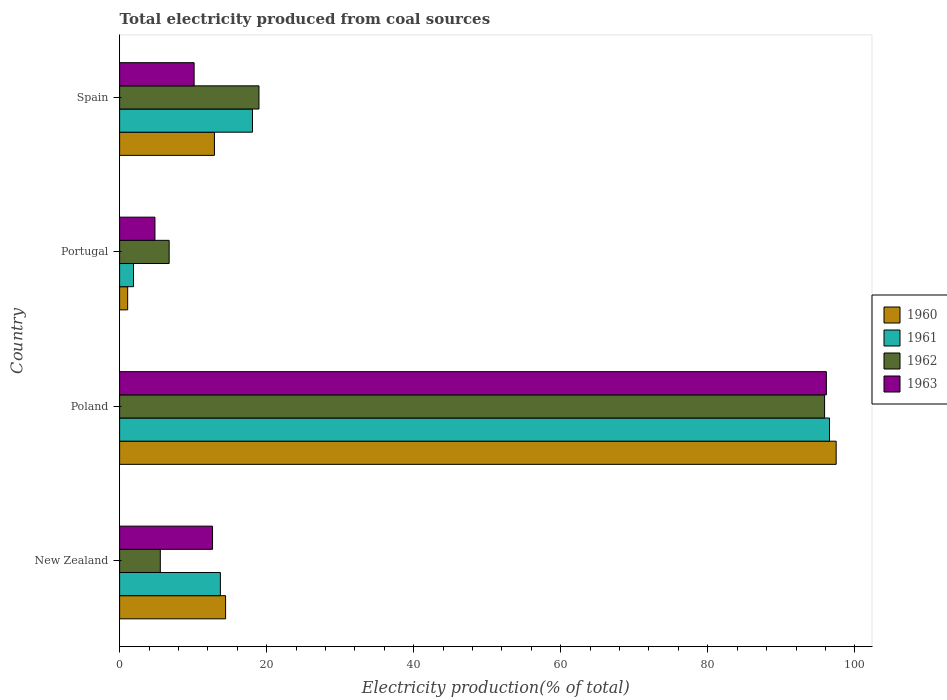How many different coloured bars are there?
Provide a short and direct response. 4. How many groups of bars are there?
Provide a short and direct response. 4. Are the number of bars on each tick of the Y-axis equal?
Provide a succinct answer. Yes. How many bars are there on the 4th tick from the top?
Ensure brevity in your answer.  4. In how many cases, is the number of bars for a given country not equal to the number of legend labels?
Offer a very short reply. 0. What is the total electricity produced in 1960 in New Zealand?
Make the answer very short. 14.42. Across all countries, what is the maximum total electricity produced in 1962?
Provide a short and direct response. 95.89. Across all countries, what is the minimum total electricity produced in 1960?
Provide a succinct answer. 1.1. In which country was the total electricity produced in 1962 minimum?
Provide a succinct answer. New Zealand. What is the total total electricity produced in 1960 in the graph?
Keep it short and to the point. 125.88. What is the difference between the total electricity produced in 1963 in New Zealand and that in Poland?
Your answer should be very brief. -83.49. What is the difference between the total electricity produced in 1962 in Poland and the total electricity produced in 1960 in Portugal?
Keep it short and to the point. 94.79. What is the average total electricity produced in 1961 per country?
Keep it short and to the point. 32.56. What is the difference between the total electricity produced in 1961 and total electricity produced in 1963 in Portugal?
Provide a succinct answer. -2.91. In how many countries, is the total electricity produced in 1963 greater than 88 %?
Your answer should be very brief. 1. What is the ratio of the total electricity produced in 1963 in Poland to that in Portugal?
Keep it short and to the point. 19.99. Is the total electricity produced in 1961 in Portugal less than that in Spain?
Ensure brevity in your answer.  Yes. Is the difference between the total electricity produced in 1961 in New Zealand and Portugal greater than the difference between the total electricity produced in 1963 in New Zealand and Portugal?
Your response must be concise. Yes. What is the difference between the highest and the second highest total electricity produced in 1962?
Offer a terse response. 76.93. What is the difference between the highest and the lowest total electricity produced in 1961?
Provide a succinct answer. 94.66. In how many countries, is the total electricity produced in 1961 greater than the average total electricity produced in 1961 taken over all countries?
Your response must be concise. 1. What does the 3rd bar from the bottom in Poland represents?
Offer a terse response. 1962. Are all the bars in the graph horizontal?
Offer a very short reply. Yes. Are the values on the major ticks of X-axis written in scientific E-notation?
Provide a succinct answer. No. Does the graph contain grids?
Your answer should be very brief. No. How many legend labels are there?
Keep it short and to the point. 4. What is the title of the graph?
Provide a short and direct response. Total electricity produced from coal sources. Does "1998" appear as one of the legend labels in the graph?
Offer a terse response. No. What is the label or title of the Y-axis?
Your answer should be very brief. Country. What is the Electricity production(% of total) in 1960 in New Zealand?
Provide a short and direct response. 14.42. What is the Electricity production(% of total) in 1961 in New Zealand?
Offer a very short reply. 13.71. What is the Electricity production(% of total) of 1962 in New Zealand?
Provide a short and direct response. 5.54. What is the Electricity production(% of total) of 1963 in New Zealand?
Give a very brief answer. 12.64. What is the Electricity production(% of total) in 1960 in Poland?
Your response must be concise. 97.46. What is the Electricity production(% of total) of 1961 in Poland?
Your answer should be compact. 96.56. What is the Electricity production(% of total) of 1962 in Poland?
Provide a succinct answer. 95.89. What is the Electricity production(% of total) in 1963 in Poland?
Your answer should be compact. 96.13. What is the Electricity production(% of total) of 1960 in Portugal?
Offer a very short reply. 1.1. What is the Electricity production(% of total) in 1961 in Portugal?
Make the answer very short. 1.89. What is the Electricity production(% of total) in 1962 in Portugal?
Offer a very short reply. 6.74. What is the Electricity production(% of total) in 1963 in Portugal?
Provide a short and direct response. 4.81. What is the Electricity production(% of total) in 1960 in Spain?
Your response must be concise. 12.9. What is the Electricity production(% of total) in 1961 in Spain?
Your answer should be compact. 18.07. What is the Electricity production(% of total) of 1962 in Spain?
Give a very brief answer. 18.96. What is the Electricity production(% of total) in 1963 in Spain?
Provide a short and direct response. 10.14. Across all countries, what is the maximum Electricity production(% of total) of 1960?
Keep it short and to the point. 97.46. Across all countries, what is the maximum Electricity production(% of total) of 1961?
Offer a very short reply. 96.56. Across all countries, what is the maximum Electricity production(% of total) in 1962?
Your answer should be compact. 95.89. Across all countries, what is the maximum Electricity production(% of total) in 1963?
Offer a terse response. 96.13. Across all countries, what is the minimum Electricity production(% of total) of 1960?
Offer a terse response. 1.1. Across all countries, what is the minimum Electricity production(% of total) of 1961?
Offer a terse response. 1.89. Across all countries, what is the minimum Electricity production(% of total) of 1962?
Make the answer very short. 5.54. Across all countries, what is the minimum Electricity production(% of total) in 1963?
Ensure brevity in your answer.  4.81. What is the total Electricity production(% of total) in 1960 in the graph?
Give a very brief answer. 125.88. What is the total Electricity production(% of total) of 1961 in the graph?
Offer a terse response. 130.23. What is the total Electricity production(% of total) of 1962 in the graph?
Provide a succinct answer. 127.12. What is the total Electricity production(% of total) of 1963 in the graph?
Keep it short and to the point. 123.72. What is the difference between the Electricity production(% of total) of 1960 in New Zealand and that in Poland?
Give a very brief answer. -83.05. What is the difference between the Electricity production(% of total) in 1961 in New Zealand and that in Poland?
Offer a terse response. -82.85. What is the difference between the Electricity production(% of total) in 1962 in New Zealand and that in Poland?
Offer a very short reply. -90.35. What is the difference between the Electricity production(% of total) of 1963 in New Zealand and that in Poland?
Keep it short and to the point. -83.49. What is the difference between the Electricity production(% of total) in 1960 in New Zealand and that in Portugal?
Make the answer very short. 13.32. What is the difference between the Electricity production(% of total) of 1961 in New Zealand and that in Portugal?
Your answer should be compact. 11.81. What is the difference between the Electricity production(% of total) of 1962 in New Zealand and that in Portugal?
Your answer should be compact. -1.2. What is the difference between the Electricity production(% of total) of 1963 in New Zealand and that in Portugal?
Ensure brevity in your answer.  7.83. What is the difference between the Electricity production(% of total) of 1960 in New Zealand and that in Spain?
Make the answer very short. 1.52. What is the difference between the Electricity production(% of total) of 1961 in New Zealand and that in Spain?
Your response must be concise. -4.36. What is the difference between the Electricity production(% of total) of 1962 in New Zealand and that in Spain?
Provide a succinct answer. -13.42. What is the difference between the Electricity production(% of total) of 1963 in New Zealand and that in Spain?
Offer a terse response. 2.5. What is the difference between the Electricity production(% of total) in 1960 in Poland and that in Portugal?
Ensure brevity in your answer.  96.36. What is the difference between the Electricity production(% of total) in 1961 in Poland and that in Portugal?
Offer a very short reply. 94.66. What is the difference between the Electricity production(% of total) in 1962 in Poland and that in Portugal?
Offer a very short reply. 89.15. What is the difference between the Electricity production(% of total) in 1963 in Poland and that in Portugal?
Your answer should be compact. 91.32. What is the difference between the Electricity production(% of total) in 1960 in Poland and that in Spain?
Offer a terse response. 84.56. What is the difference between the Electricity production(% of total) in 1961 in Poland and that in Spain?
Your answer should be very brief. 78.49. What is the difference between the Electricity production(% of total) in 1962 in Poland and that in Spain?
Keep it short and to the point. 76.93. What is the difference between the Electricity production(% of total) of 1963 in Poland and that in Spain?
Your answer should be compact. 86. What is the difference between the Electricity production(% of total) of 1960 in Portugal and that in Spain?
Make the answer very short. -11.8. What is the difference between the Electricity production(% of total) in 1961 in Portugal and that in Spain?
Provide a short and direct response. -16.18. What is the difference between the Electricity production(% of total) in 1962 in Portugal and that in Spain?
Offer a terse response. -12.22. What is the difference between the Electricity production(% of total) in 1963 in Portugal and that in Spain?
Your answer should be very brief. -5.33. What is the difference between the Electricity production(% of total) in 1960 in New Zealand and the Electricity production(% of total) in 1961 in Poland?
Ensure brevity in your answer.  -82.14. What is the difference between the Electricity production(% of total) of 1960 in New Zealand and the Electricity production(% of total) of 1962 in Poland?
Your answer should be compact. -81.47. What is the difference between the Electricity production(% of total) of 1960 in New Zealand and the Electricity production(% of total) of 1963 in Poland?
Your answer should be very brief. -81.71. What is the difference between the Electricity production(% of total) in 1961 in New Zealand and the Electricity production(% of total) in 1962 in Poland?
Provide a short and direct response. -82.18. What is the difference between the Electricity production(% of total) of 1961 in New Zealand and the Electricity production(% of total) of 1963 in Poland?
Provide a short and direct response. -82.42. What is the difference between the Electricity production(% of total) of 1962 in New Zealand and the Electricity production(% of total) of 1963 in Poland?
Offer a terse response. -90.6. What is the difference between the Electricity production(% of total) in 1960 in New Zealand and the Electricity production(% of total) in 1961 in Portugal?
Offer a very short reply. 12.52. What is the difference between the Electricity production(% of total) of 1960 in New Zealand and the Electricity production(% of total) of 1962 in Portugal?
Ensure brevity in your answer.  7.68. What is the difference between the Electricity production(% of total) of 1960 in New Zealand and the Electricity production(% of total) of 1963 in Portugal?
Offer a very short reply. 9.61. What is the difference between the Electricity production(% of total) of 1961 in New Zealand and the Electricity production(% of total) of 1962 in Portugal?
Offer a very short reply. 6.97. What is the difference between the Electricity production(% of total) in 1961 in New Zealand and the Electricity production(% of total) in 1963 in Portugal?
Offer a terse response. 8.9. What is the difference between the Electricity production(% of total) of 1962 in New Zealand and the Electricity production(% of total) of 1963 in Portugal?
Your answer should be compact. 0.73. What is the difference between the Electricity production(% of total) of 1960 in New Zealand and the Electricity production(% of total) of 1961 in Spain?
Provide a succinct answer. -3.65. What is the difference between the Electricity production(% of total) of 1960 in New Zealand and the Electricity production(% of total) of 1962 in Spain?
Give a very brief answer. -4.54. What is the difference between the Electricity production(% of total) in 1960 in New Zealand and the Electricity production(% of total) in 1963 in Spain?
Your answer should be compact. 4.28. What is the difference between the Electricity production(% of total) of 1961 in New Zealand and the Electricity production(% of total) of 1962 in Spain?
Make the answer very short. -5.25. What is the difference between the Electricity production(% of total) of 1961 in New Zealand and the Electricity production(% of total) of 1963 in Spain?
Make the answer very short. 3.57. What is the difference between the Electricity production(% of total) in 1962 in New Zealand and the Electricity production(% of total) in 1963 in Spain?
Ensure brevity in your answer.  -4.6. What is the difference between the Electricity production(% of total) in 1960 in Poland and the Electricity production(% of total) in 1961 in Portugal?
Your answer should be compact. 95.57. What is the difference between the Electricity production(% of total) of 1960 in Poland and the Electricity production(% of total) of 1962 in Portugal?
Your response must be concise. 90.72. What is the difference between the Electricity production(% of total) in 1960 in Poland and the Electricity production(% of total) in 1963 in Portugal?
Provide a succinct answer. 92.65. What is the difference between the Electricity production(% of total) in 1961 in Poland and the Electricity production(% of total) in 1962 in Portugal?
Your answer should be compact. 89.82. What is the difference between the Electricity production(% of total) of 1961 in Poland and the Electricity production(% of total) of 1963 in Portugal?
Your response must be concise. 91.75. What is the difference between the Electricity production(% of total) of 1962 in Poland and the Electricity production(% of total) of 1963 in Portugal?
Offer a terse response. 91.08. What is the difference between the Electricity production(% of total) in 1960 in Poland and the Electricity production(% of total) in 1961 in Spain?
Your answer should be compact. 79.39. What is the difference between the Electricity production(% of total) in 1960 in Poland and the Electricity production(% of total) in 1962 in Spain?
Provide a succinct answer. 78.51. What is the difference between the Electricity production(% of total) in 1960 in Poland and the Electricity production(% of total) in 1963 in Spain?
Your answer should be very brief. 87.33. What is the difference between the Electricity production(% of total) in 1961 in Poland and the Electricity production(% of total) in 1962 in Spain?
Provide a short and direct response. 77.6. What is the difference between the Electricity production(% of total) in 1961 in Poland and the Electricity production(% of total) in 1963 in Spain?
Provide a succinct answer. 86.42. What is the difference between the Electricity production(% of total) of 1962 in Poland and the Electricity production(% of total) of 1963 in Spain?
Keep it short and to the point. 85.75. What is the difference between the Electricity production(% of total) in 1960 in Portugal and the Electricity production(% of total) in 1961 in Spain?
Your answer should be compact. -16.97. What is the difference between the Electricity production(% of total) in 1960 in Portugal and the Electricity production(% of total) in 1962 in Spain?
Keep it short and to the point. -17.86. What is the difference between the Electricity production(% of total) of 1960 in Portugal and the Electricity production(% of total) of 1963 in Spain?
Your answer should be compact. -9.04. What is the difference between the Electricity production(% of total) in 1961 in Portugal and the Electricity production(% of total) in 1962 in Spain?
Make the answer very short. -17.06. What is the difference between the Electricity production(% of total) of 1961 in Portugal and the Electricity production(% of total) of 1963 in Spain?
Offer a very short reply. -8.24. What is the difference between the Electricity production(% of total) of 1962 in Portugal and the Electricity production(% of total) of 1963 in Spain?
Offer a very short reply. -3.4. What is the average Electricity production(% of total) of 1960 per country?
Provide a succinct answer. 31.47. What is the average Electricity production(% of total) in 1961 per country?
Offer a terse response. 32.56. What is the average Electricity production(% of total) in 1962 per country?
Ensure brevity in your answer.  31.78. What is the average Electricity production(% of total) of 1963 per country?
Ensure brevity in your answer.  30.93. What is the difference between the Electricity production(% of total) in 1960 and Electricity production(% of total) in 1961 in New Zealand?
Ensure brevity in your answer.  0.71. What is the difference between the Electricity production(% of total) in 1960 and Electricity production(% of total) in 1962 in New Zealand?
Give a very brief answer. 8.88. What is the difference between the Electricity production(% of total) of 1960 and Electricity production(% of total) of 1963 in New Zealand?
Your response must be concise. 1.78. What is the difference between the Electricity production(% of total) in 1961 and Electricity production(% of total) in 1962 in New Zealand?
Your response must be concise. 8.17. What is the difference between the Electricity production(% of total) in 1961 and Electricity production(% of total) in 1963 in New Zealand?
Ensure brevity in your answer.  1.07. What is the difference between the Electricity production(% of total) of 1962 and Electricity production(% of total) of 1963 in New Zealand?
Offer a terse response. -7.1. What is the difference between the Electricity production(% of total) in 1960 and Electricity production(% of total) in 1961 in Poland?
Your response must be concise. 0.91. What is the difference between the Electricity production(% of total) in 1960 and Electricity production(% of total) in 1962 in Poland?
Offer a terse response. 1.57. What is the difference between the Electricity production(% of total) of 1960 and Electricity production(% of total) of 1963 in Poland?
Your response must be concise. 1.33. What is the difference between the Electricity production(% of total) in 1961 and Electricity production(% of total) in 1962 in Poland?
Offer a very short reply. 0.67. What is the difference between the Electricity production(% of total) in 1961 and Electricity production(% of total) in 1963 in Poland?
Provide a short and direct response. 0.43. What is the difference between the Electricity production(% of total) in 1962 and Electricity production(% of total) in 1963 in Poland?
Offer a very short reply. -0.24. What is the difference between the Electricity production(% of total) in 1960 and Electricity production(% of total) in 1961 in Portugal?
Provide a short and direct response. -0.8. What is the difference between the Electricity production(% of total) of 1960 and Electricity production(% of total) of 1962 in Portugal?
Provide a succinct answer. -5.64. What is the difference between the Electricity production(% of total) in 1960 and Electricity production(% of total) in 1963 in Portugal?
Offer a very short reply. -3.71. What is the difference between the Electricity production(% of total) in 1961 and Electricity production(% of total) in 1962 in Portugal?
Ensure brevity in your answer.  -4.85. What is the difference between the Electricity production(% of total) in 1961 and Electricity production(% of total) in 1963 in Portugal?
Offer a very short reply. -2.91. What is the difference between the Electricity production(% of total) in 1962 and Electricity production(% of total) in 1963 in Portugal?
Your answer should be very brief. 1.93. What is the difference between the Electricity production(% of total) in 1960 and Electricity production(% of total) in 1961 in Spain?
Your answer should be very brief. -5.17. What is the difference between the Electricity production(% of total) in 1960 and Electricity production(% of total) in 1962 in Spain?
Your answer should be very brief. -6.06. What is the difference between the Electricity production(% of total) of 1960 and Electricity production(% of total) of 1963 in Spain?
Give a very brief answer. 2.76. What is the difference between the Electricity production(% of total) of 1961 and Electricity production(% of total) of 1962 in Spain?
Your answer should be very brief. -0.88. What is the difference between the Electricity production(% of total) of 1961 and Electricity production(% of total) of 1963 in Spain?
Ensure brevity in your answer.  7.94. What is the difference between the Electricity production(% of total) in 1962 and Electricity production(% of total) in 1963 in Spain?
Make the answer very short. 8.82. What is the ratio of the Electricity production(% of total) in 1960 in New Zealand to that in Poland?
Your answer should be very brief. 0.15. What is the ratio of the Electricity production(% of total) in 1961 in New Zealand to that in Poland?
Provide a succinct answer. 0.14. What is the ratio of the Electricity production(% of total) in 1962 in New Zealand to that in Poland?
Offer a very short reply. 0.06. What is the ratio of the Electricity production(% of total) of 1963 in New Zealand to that in Poland?
Ensure brevity in your answer.  0.13. What is the ratio of the Electricity production(% of total) in 1960 in New Zealand to that in Portugal?
Your response must be concise. 13.13. What is the ratio of the Electricity production(% of total) in 1961 in New Zealand to that in Portugal?
Keep it short and to the point. 7.24. What is the ratio of the Electricity production(% of total) in 1962 in New Zealand to that in Portugal?
Provide a short and direct response. 0.82. What is the ratio of the Electricity production(% of total) of 1963 in New Zealand to that in Portugal?
Your answer should be compact. 2.63. What is the ratio of the Electricity production(% of total) in 1960 in New Zealand to that in Spain?
Keep it short and to the point. 1.12. What is the ratio of the Electricity production(% of total) in 1961 in New Zealand to that in Spain?
Your answer should be very brief. 0.76. What is the ratio of the Electricity production(% of total) of 1962 in New Zealand to that in Spain?
Ensure brevity in your answer.  0.29. What is the ratio of the Electricity production(% of total) of 1963 in New Zealand to that in Spain?
Ensure brevity in your answer.  1.25. What is the ratio of the Electricity production(% of total) in 1960 in Poland to that in Portugal?
Offer a terse response. 88.77. What is the ratio of the Electricity production(% of total) in 1961 in Poland to that in Portugal?
Keep it short and to the point. 50.97. What is the ratio of the Electricity production(% of total) in 1962 in Poland to that in Portugal?
Your answer should be very brief. 14.23. What is the ratio of the Electricity production(% of total) of 1963 in Poland to that in Portugal?
Make the answer very short. 19.99. What is the ratio of the Electricity production(% of total) of 1960 in Poland to that in Spain?
Ensure brevity in your answer.  7.56. What is the ratio of the Electricity production(% of total) of 1961 in Poland to that in Spain?
Provide a short and direct response. 5.34. What is the ratio of the Electricity production(% of total) in 1962 in Poland to that in Spain?
Provide a short and direct response. 5.06. What is the ratio of the Electricity production(% of total) in 1963 in Poland to that in Spain?
Offer a very short reply. 9.48. What is the ratio of the Electricity production(% of total) of 1960 in Portugal to that in Spain?
Offer a very short reply. 0.09. What is the ratio of the Electricity production(% of total) of 1961 in Portugal to that in Spain?
Provide a short and direct response. 0.1. What is the ratio of the Electricity production(% of total) in 1962 in Portugal to that in Spain?
Offer a terse response. 0.36. What is the ratio of the Electricity production(% of total) of 1963 in Portugal to that in Spain?
Offer a very short reply. 0.47. What is the difference between the highest and the second highest Electricity production(% of total) in 1960?
Provide a short and direct response. 83.05. What is the difference between the highest and the second highest Electricity production(% of total) in 1961?
Provide a short and direct response. 78.49. What is the difference between the highest and the second highest Electricity production(% of total) of 1962?
Ensure brevity in your answer.  76.93. What is the difference between the highest and the second highest Electricity production(% of total) of 1963?
Ensure brevity in your answer.  83.49. What is the difference between the highest and the lowest Electricity production(% of total) of 1960?
Your answer should be very brief. 96.36. What is the difference between the highest and the lowest Electricity production(% of total) of 1961?
Provide a short and direct response. 94.66. What is the difference between the highest and the lowest Electricity production(% of total) of 1962?
Your answer should be very brief. 90.35. What is the difference between the highest and the lowest Electricity production(% of total) in 1963?
Your answer should be very brief. 91.32. 